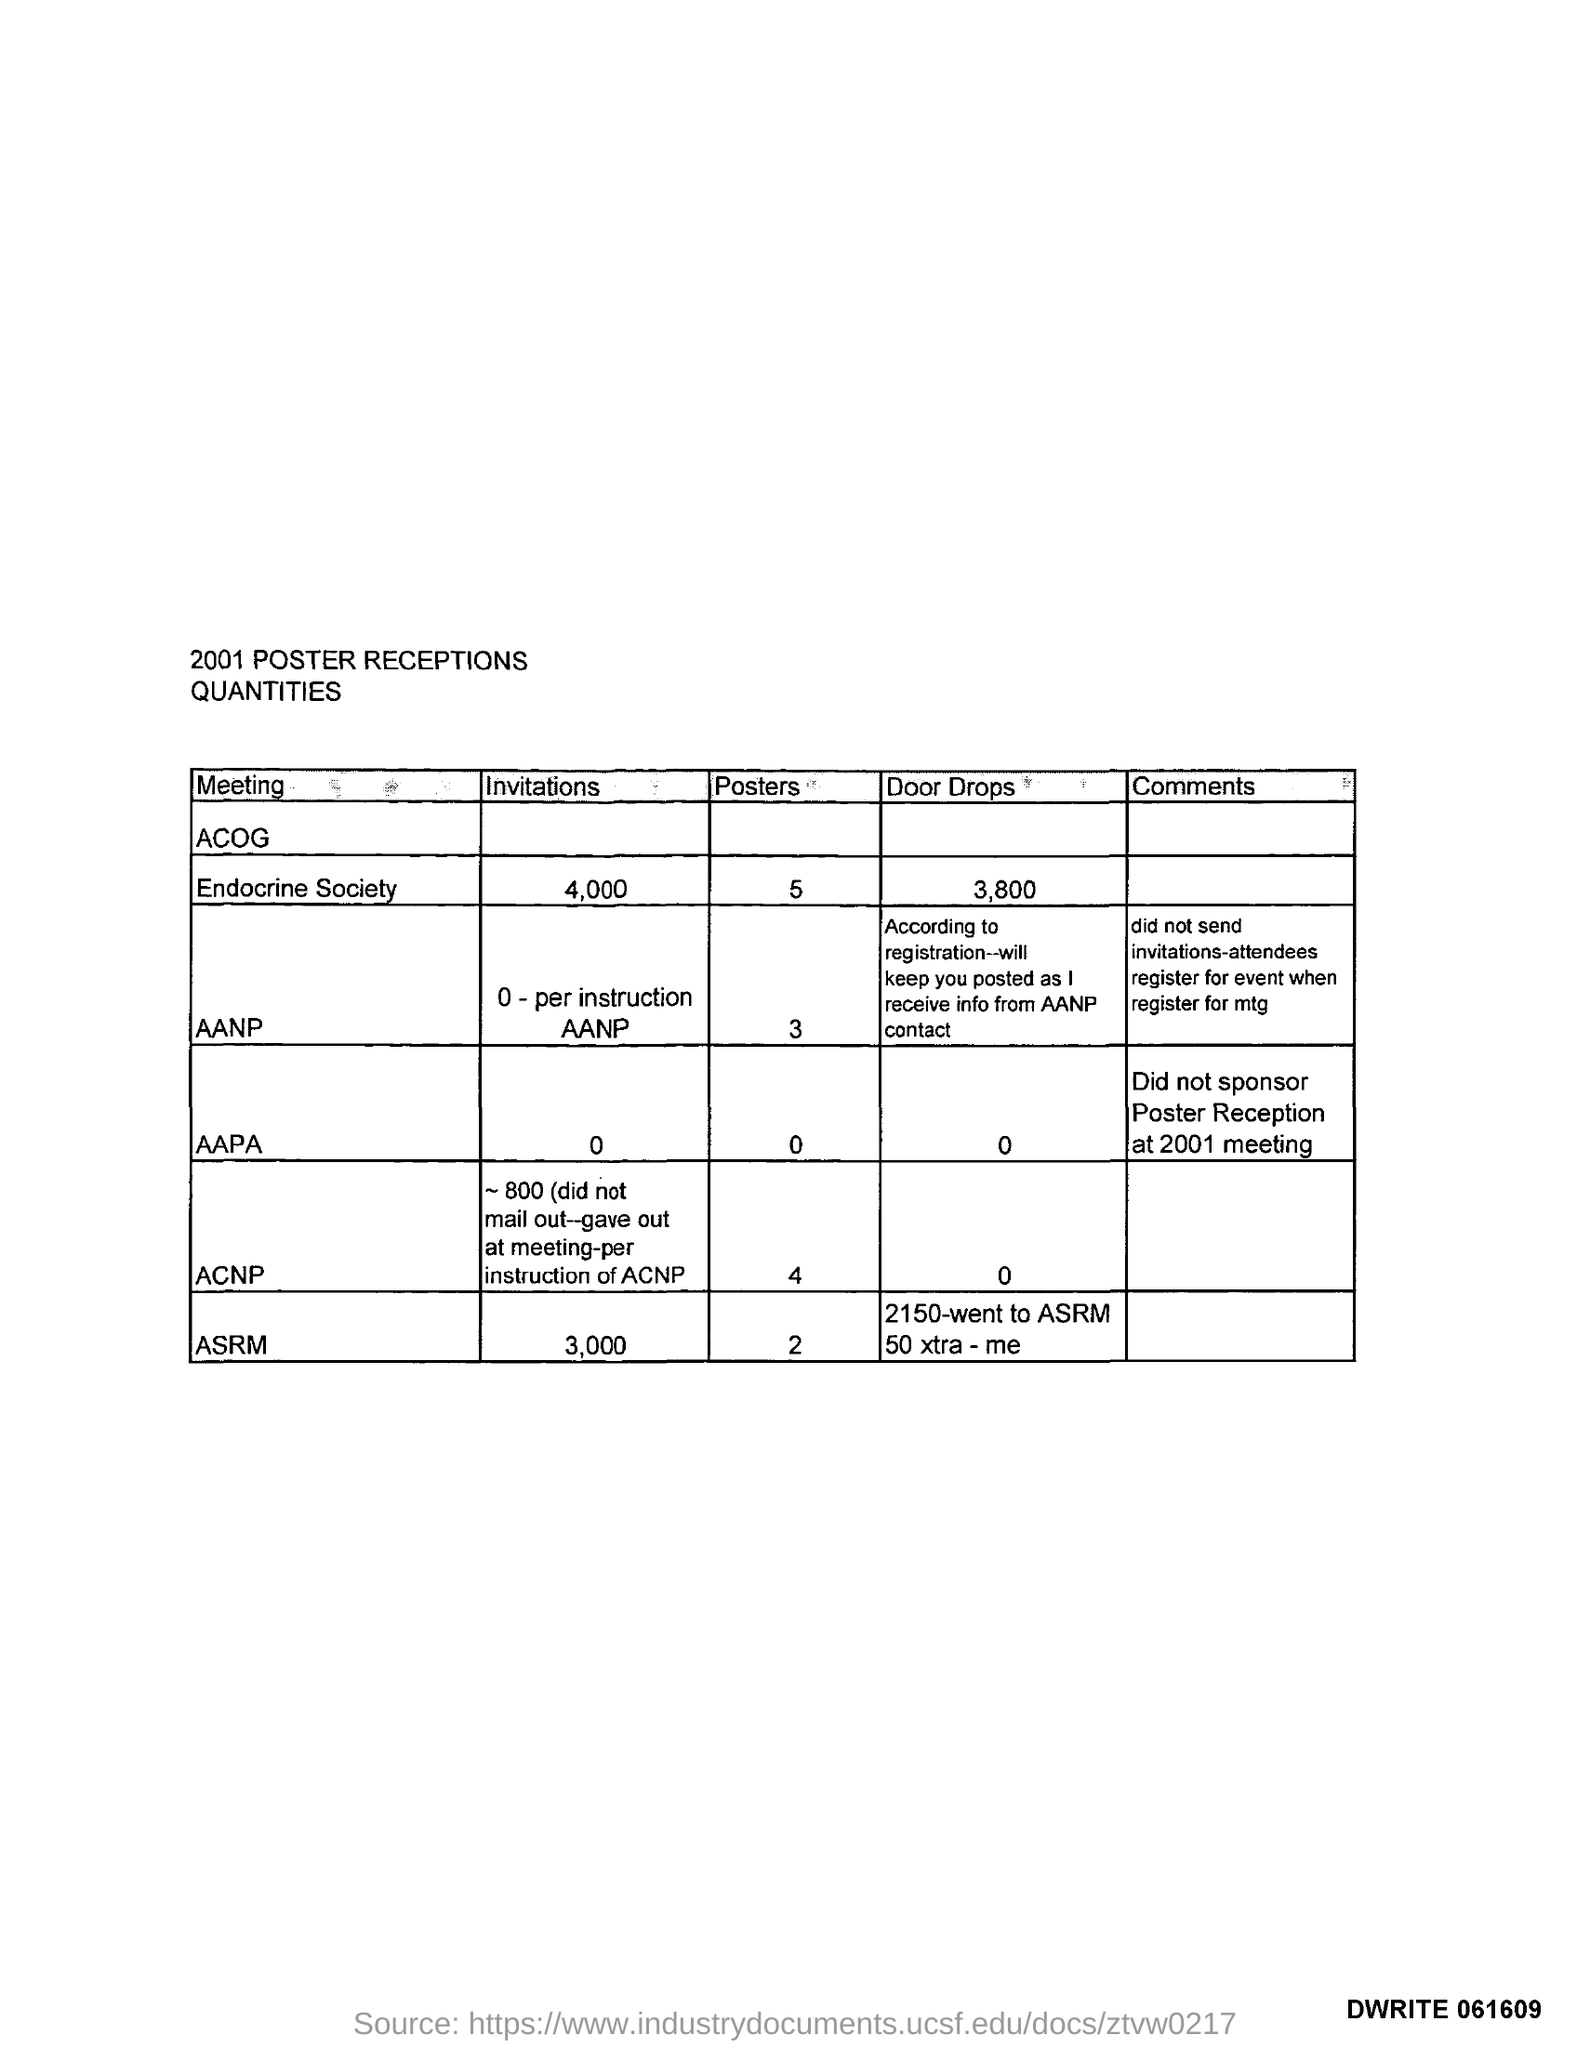Specify some key components in this picture. The given table is titled '2001 POSTER RECEPTIONS QUANTITIES.' I have not received any invitations for the AANP event, as per the instructions provided by AANP. There are two posters for the American Society for Reproductive Medicine (ASRM). The Endocrine Society received 3,800 door drops. The American Association of Physical Anthropologists (AAPA) did not sponsor the Poster Reception at the 2001 meeting. 